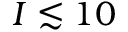<formula> <loc_0><loc_0><loc_500><loc_500>I \lesssim 1 0</formula> 